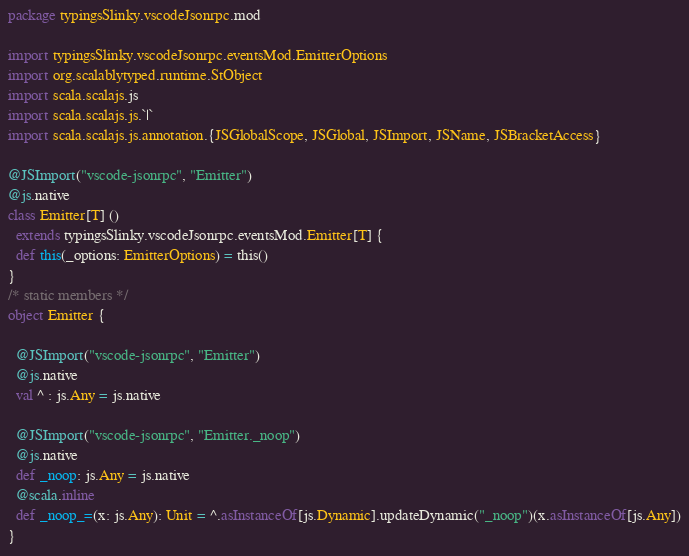<code> <loc_0><loc_0><loc_500><loc_500><_Scala_>package typingsSlinky.vscodeJsonrpc.mod

import typingsSlinky.vscodeJsonrpc.eventsMod.EmitterOptions
import org.scalablytyped.runtime.StObject
import scala.scalajs.js
import scala.scalajs.js.`|`
import scala.scalajs.js.annotation.{JSGlobalScope, JSGlobal, JSImport, JSName, JSBracketAccess}

@JSImport("vscode-jsonrpc", "Emitter")
@js.native
class Emitter[T] ()
  extends typingsSlinky.vscodeJsonrpc.eventsMod.Emitter[T] {
  def this(_options: EmitterOptions) = this()
}
/* static members */
object Emitter {
  
  @JSImport("vscode-jsonrpc", "Emitter")
  @js.native
  val ^ : js.Any = js.native
  
  @JSImport("vscode-jsonrpc", "Emitter._noop")
  @js.native
  def _noop: js.Any = js.native
  @scala.inline
  def _noop_=(x: js.Any): Unit = ^.asInstanceOf[js.Dynamic].updateDynamic("_noop")(x.asInstanceOf[js.Any])
}
</code> 